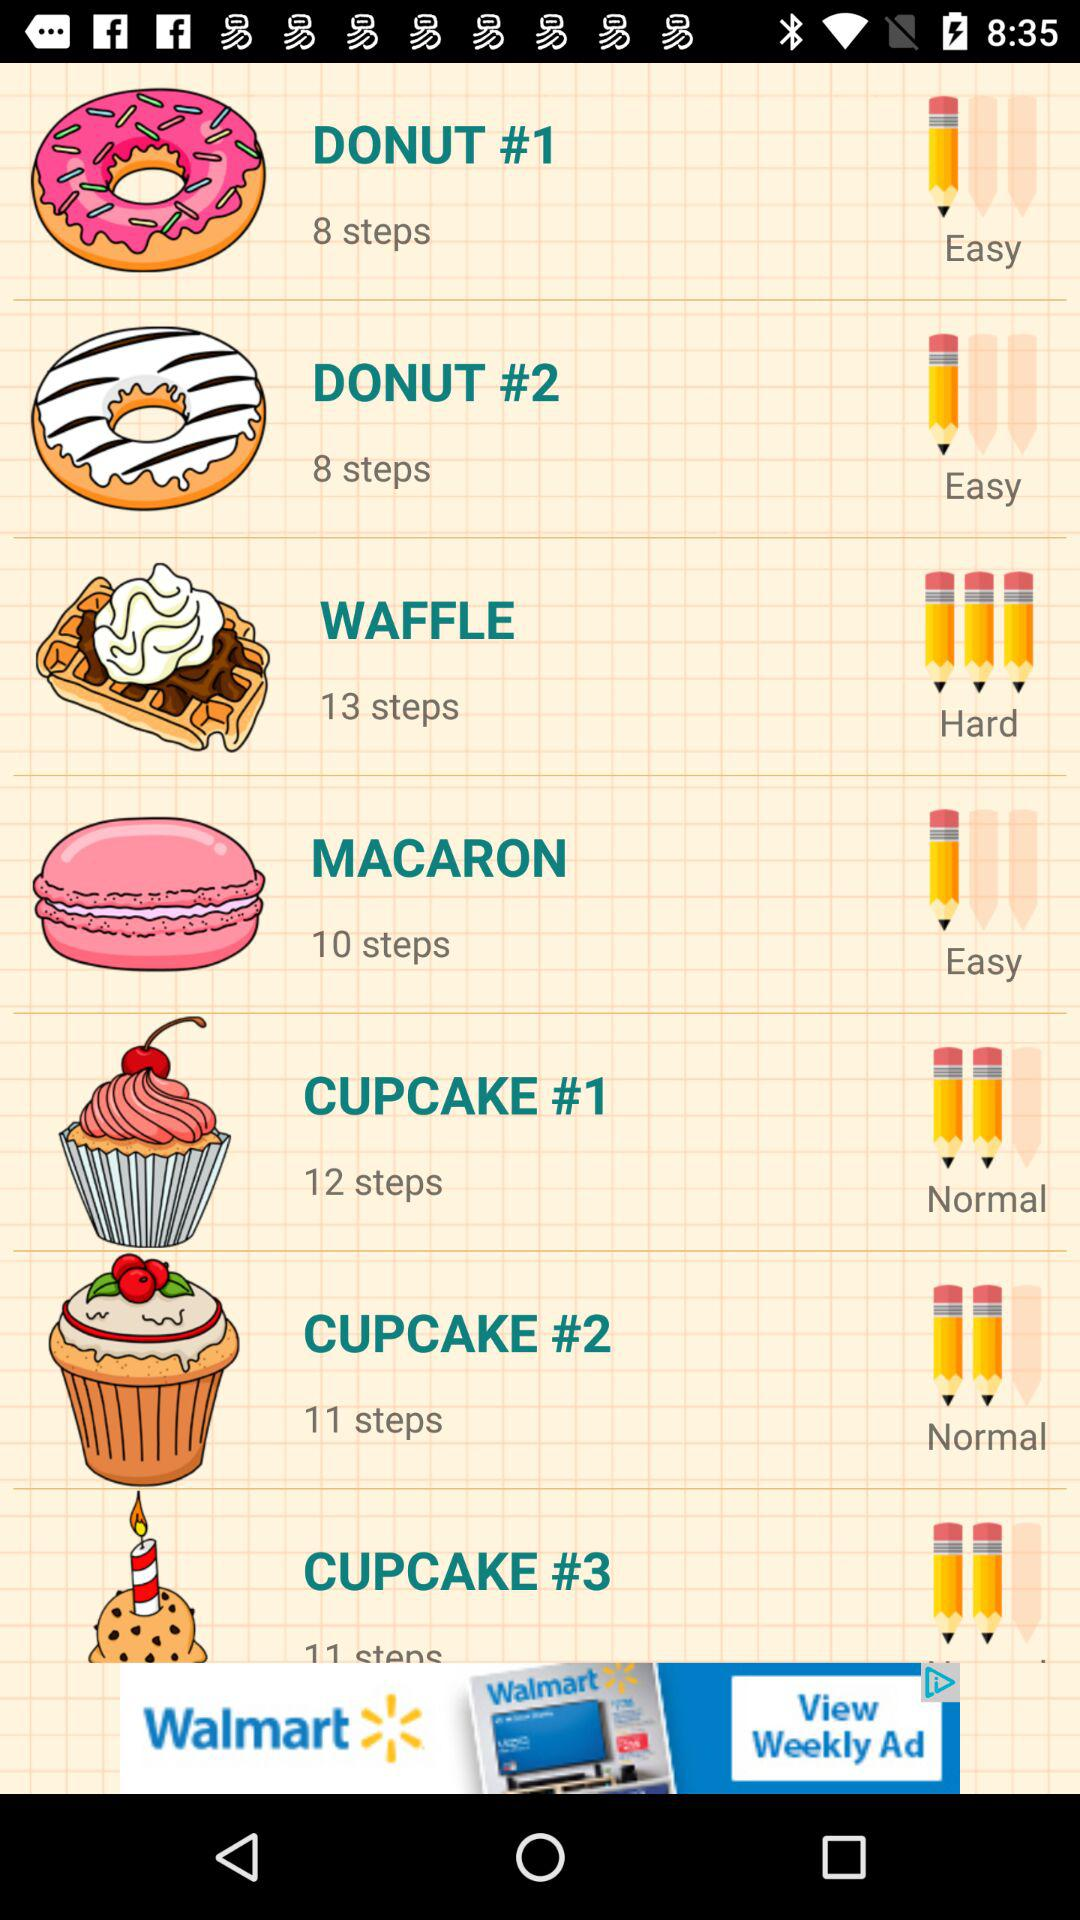How many steps are shown in the "WAFFLE"? There are 13 steps shown in the "WAFFLE". 